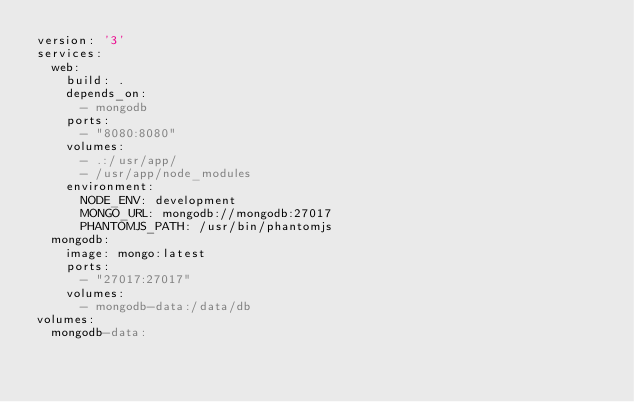<code> <loc_0><loc_0><loc_500><loc_500><_YAML_>version: '3'
services:
  web:
    build: .
    depends_on:
      - mongodb
    ports:
      - "8080:8080"
    volumes:
      - .:/usr/app/
      - /usr/app/node_modules
    environment:
      NODE_ENV: development
      MONGO_URL: mongodb://mongodb:27017
      PHANTOMJS_PATH: /usr/bin/phantomjs
  mongodb:
    image: mongo:latest
    ports:
      - "27017:27017"
    volumes:
      - mongodb-data:/data/db
volumes:
  mongodb-data:
</code> 